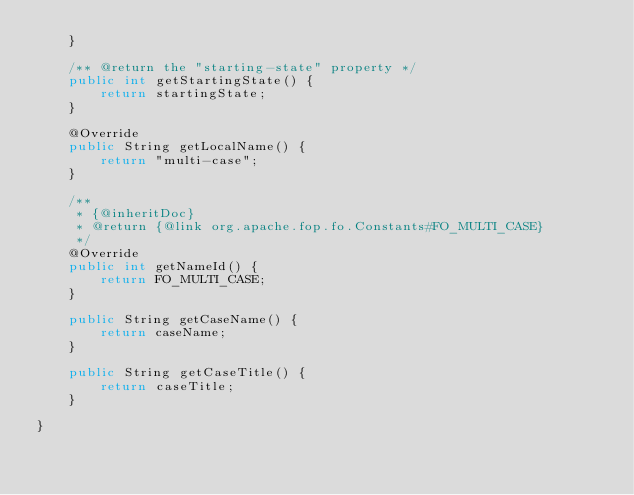Convert code to text. <code><loc_0><loc_0><loc_500><loc_500><_Java_>    }

    /** @return the "starting-state" property */
    public int getStartingState() {
        return startingState;
    }

    @Override
    public String getLocalName() {
        return "multi-case";
    }

    /**
     * {@inheritDoc}
     * @return {@link org.apache.fop.fo.Constants#FO_MULTI_CASE}
     */
    @Override
    public int getNameId() {
        return FO_MULTI_CASE;
    }

    public String getCaseName() {
        return caseName;
    }

    public String getCaseTitle() {
        return caseTitle;
    }

}
</code> 